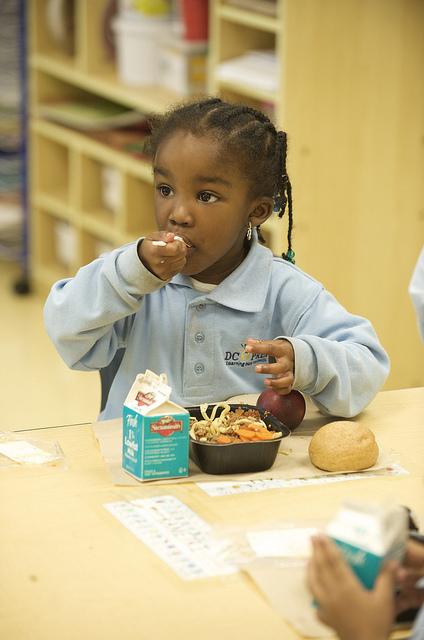What color is her shirt?
Answer briefly. Blue. Is this a healthy meal to eat every day?
Short answer required. Yes. What color is the milk inside the carton?
Quick response, please. White. How many different drinks are there?
Be succinct. 1. What is the color of the milk carton?
Be succinct. Blue. Is she young?
Keep it brief. Yes. What sharp object should the child not point at his face?
Answer briefly. Knife. What is she holding in her hand?
Give a very brief answer. Spoon. What is this kid doing?
Give a very brief answer. Eating. What is the woman eating?
Be succinct. Food. Could she be married?
Give a very brief answer. No. 